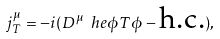Convert formula to latex. <formula><loc_0><loc_0><loc_500><loc_500>j _ { T } ^ { \mu } = - i ( D ^ { \mu } \ h e \phi T \phi - \text {h.c.} ) ,</formula> 